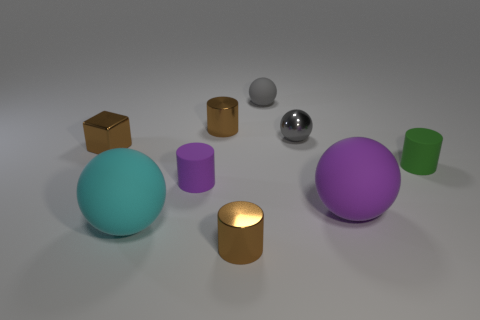Subtract 1 cylinders. How many cylinders are left? 3 Subtract all cyan cylinders. Subtract all gray balls. How many cylinders are left? 4 Add 1 big purple rubber balls. How many objects exist? 10 Subtract all cubes. How many objects are left? 8 Subtract all purple cylinders. Subtract all small balls. How many objects are left? 6 Add 5 large cyan objects. How many large cyan objects are left? 6 Add 8 purple rubber spheres. How many purple rubber spheres exist? 9 Subtract 0 yellow blocks. How many objects are left? 9 